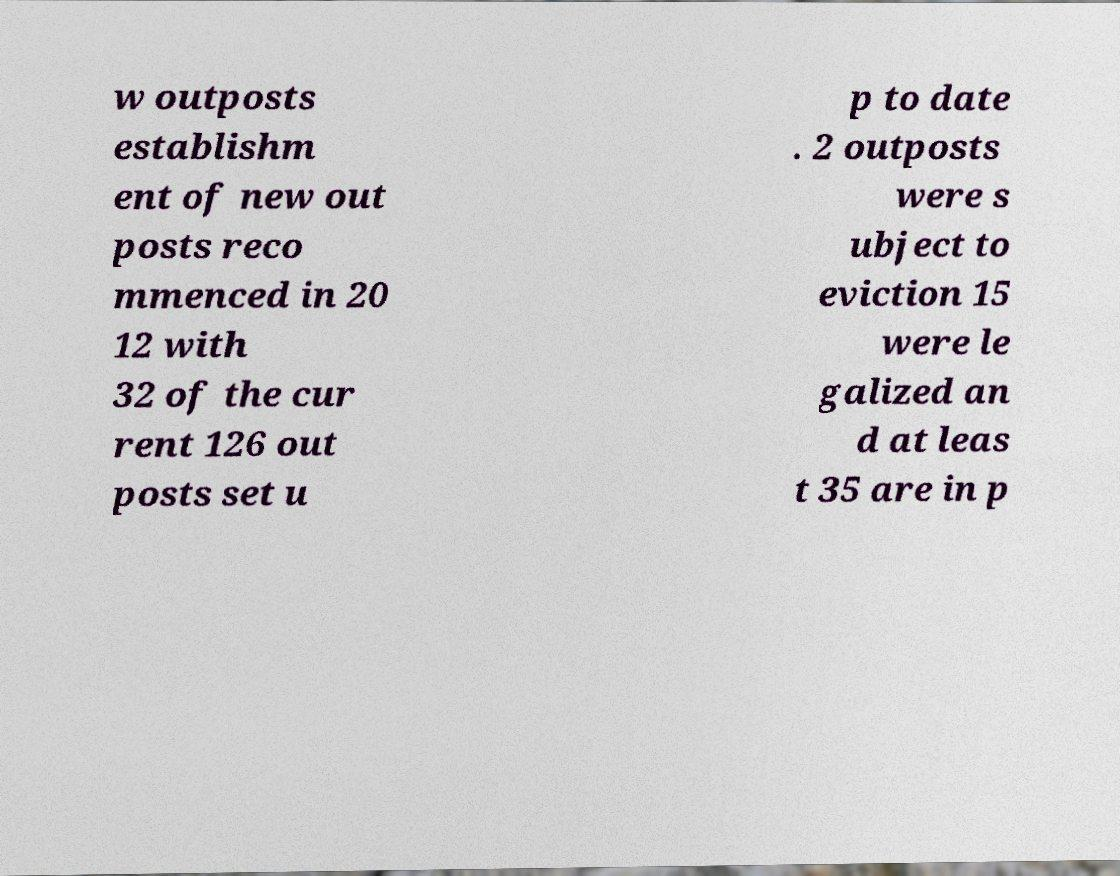For documentation purposes, I need the text within this image transcribed. Could you provide that? w outposts establishm ent of new out posts reco mmenced in 20 12 with 32 of the cur rent 126 out posts set u p to date . 2 outposts were s ubject to eviction 15 were le galized an d at leas t 35 are in p 